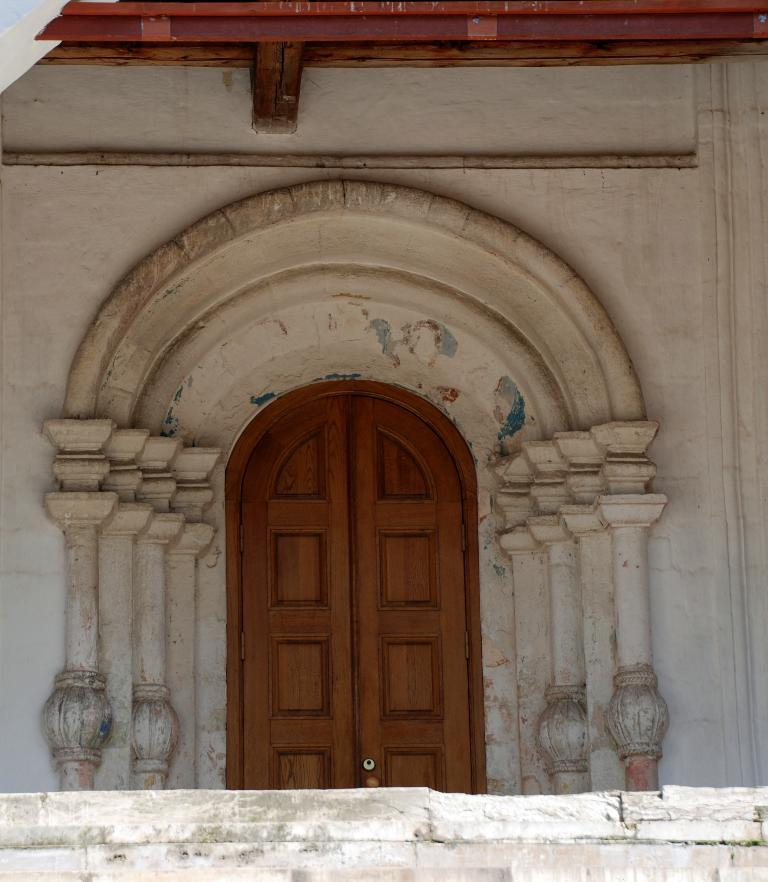What type of door is visible in the image? There is a wooden door in the image. What decorative item can be seen on the wall in the image? There is a sculpture on the wall in the image. What is in front of the wooden door? There is a wall in front of the wooden door. What type of roof is present in the image? There is a wooden roof in the image. How many feet are visible in the image? There are no feet present in the image. Is there a parcel being delivered in the image? There is no mention of a parcel or delivery in the image. 